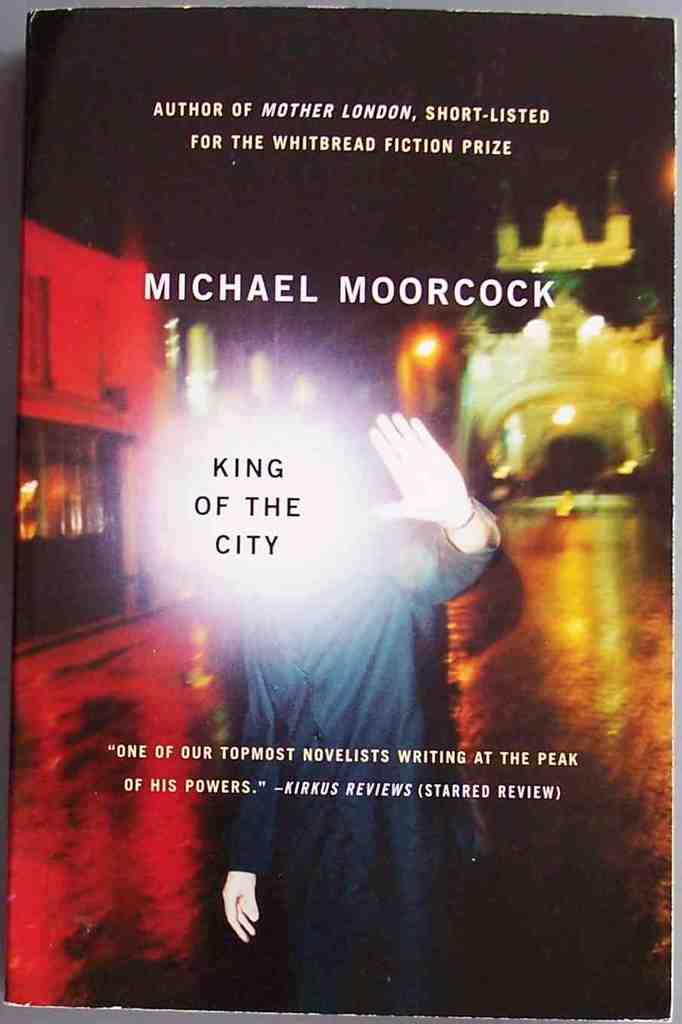What is the title of this book?
Your response must be concise. King of the city. 